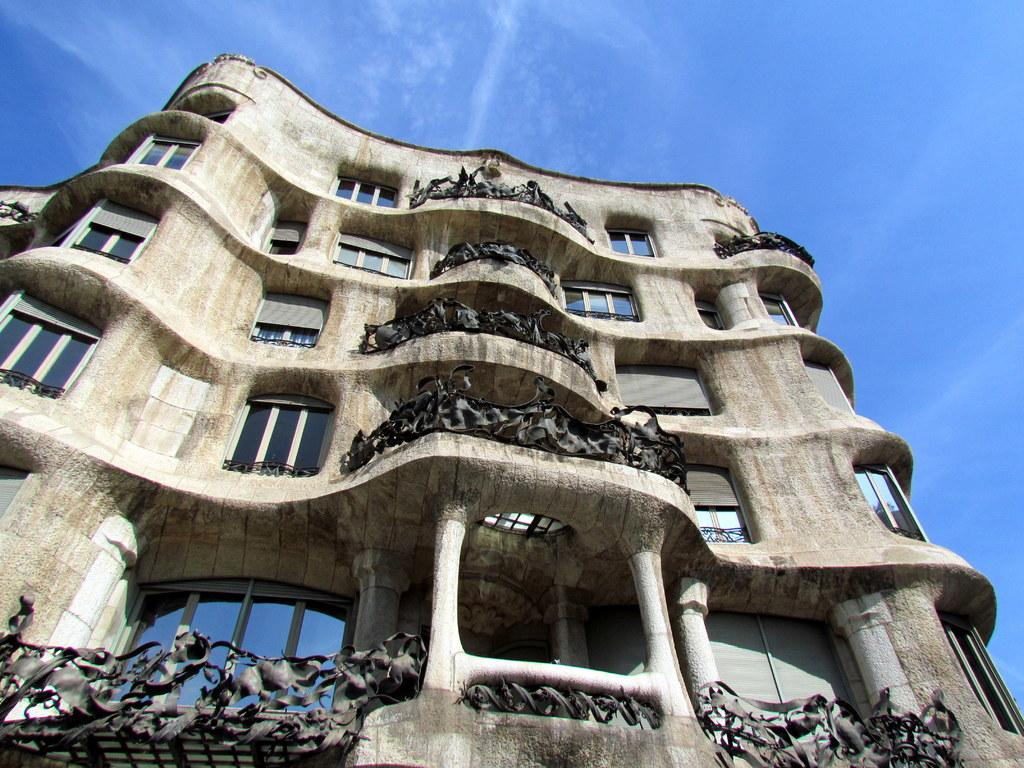What type of structure is present in the image? There is a building in the image. What features can be observed on the building? The building has windows and a railing. What is visible at the top of the image? The sky is visible at the top of the image. What word is written on the veil that is covering the building in the image? There is no veil covering the building in the image, and therefore no words can be read on it. 